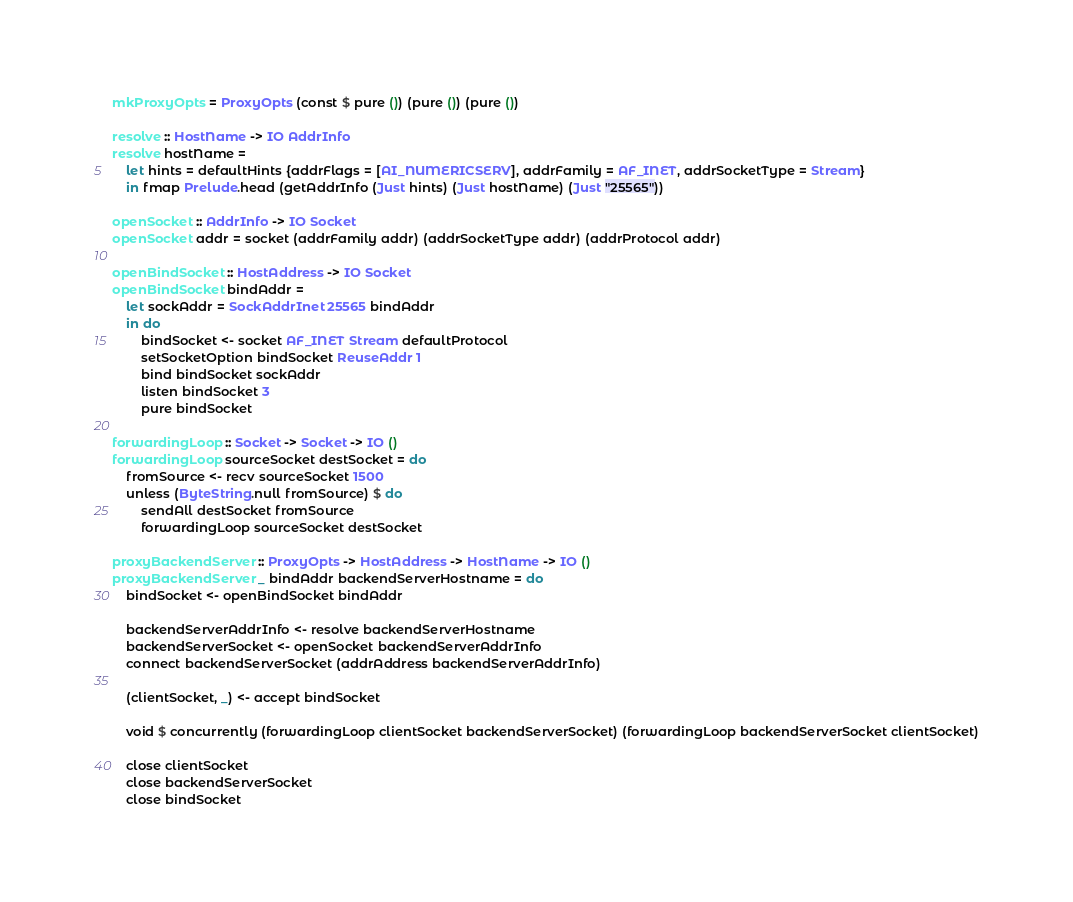<code> <loc_0><loc_0><loc_500><loc_500><_Haskell_>mkProxyOpts = ProxyOpts (const $ pure ()) (pure ()) (pure ())

resolve :: HostName -> IO AddrInfo
resolve hostName =
    let hints = defaultHints {addrFlags = [AI_NUMERICSERV], addrFamily = AF_INET, addrSocketType = Stream}
    in fmap Prelude.head (getAddrInfo (Just hints) (Just hostName) (Just "25565"))

openSocket :: AddrInfo -> IO Socket
openSocket addr = socket (addrFamily addr) (addrSocketType addr) (addrProtocol addr)

openBindSocket :: HostAddress -> IO Socket
openBindSocket bindAddr =
    let sockAddr = SockAddrInet 25565 bindAddr
    in do
        bindSocket <- socket AF_INET Stream defaultProtocol
        setSocketOption bindSocket ReuseAddr 1
        bind bindSocket sockAddr
        listen bindSocket 3
        pure bindSocket

forwardingLoop :: Socket -> Socket -> IO ()
forwardingLoop sourceSocket destSocket = do
    fromSource <- recv sourceSocket 1500
    unless (ByteString.null fromSource) $ do
        sendAll destSocket fromSource
        forwardingLoop sourceSocket destSocket

proxyBackendServer :: ProxyOpts -> HostAddress -> HostName -> IO ()
proxyBackendServer _ bindAddr backendServerHostname = do
    bindSocket <- openBindSocket bindAddr

    backendServerAddrInfo <- resolve backendServerHostname
    backendServerSocket <- openSocket backendServerAddrInfo
    connect backendServerSocket (addrAddress backendServerAddrInfo)

    (clientSocket, _) <- accept bindSocket

    void $ concurrently (forwardingLoop clientSocket backendServerSocket) (forwardingLoop backendServerSocket clientSocket)

    close clientSocket
    close backendServerSocket
    close bindSocket
</code> 